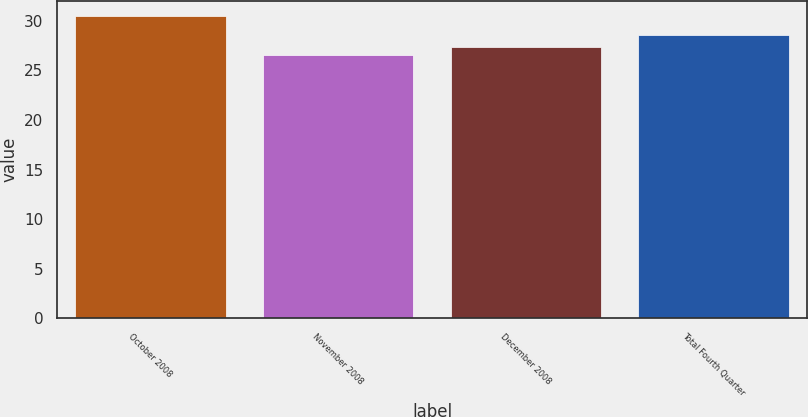Convert chart. <chart><loc_0><loc_0><loc_500><loc_500><bar_chart><fcel>October 2008<fcel>November 2008<fcel>December 2008<fcel>Total Fourth Quarter<nl><fcel>30.51<fcel>26.51<fcel>27.32<fcel>28.53<nl></chart> 